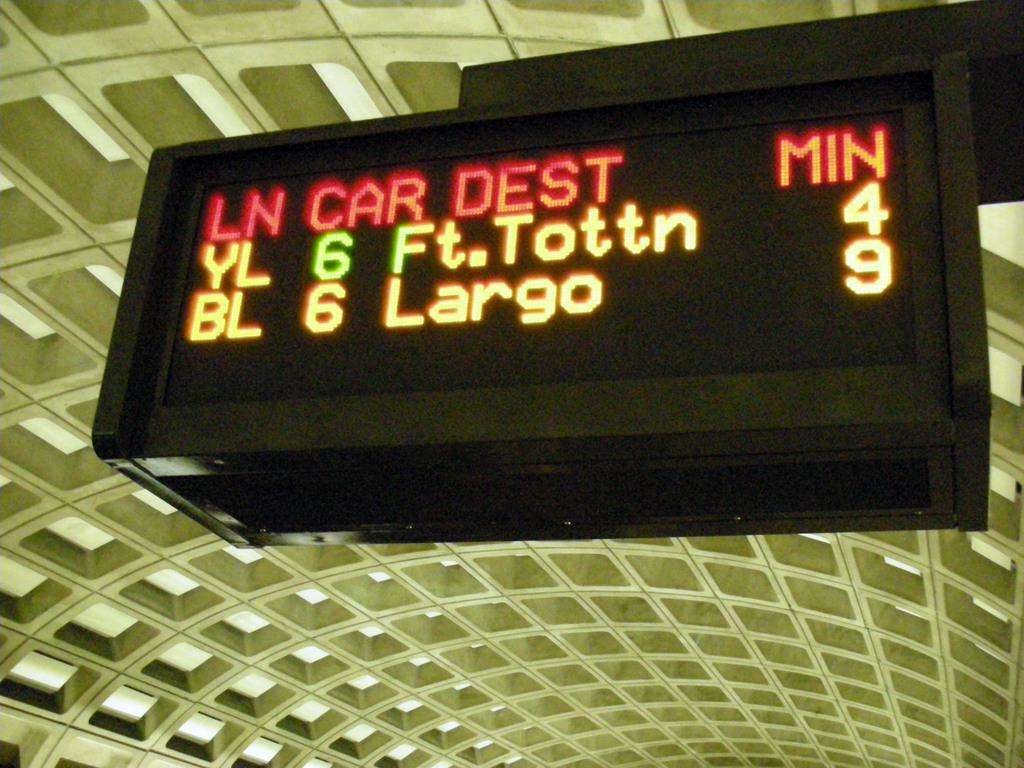What is indicated by the far right column?
Provide a succinct answer. Min. 